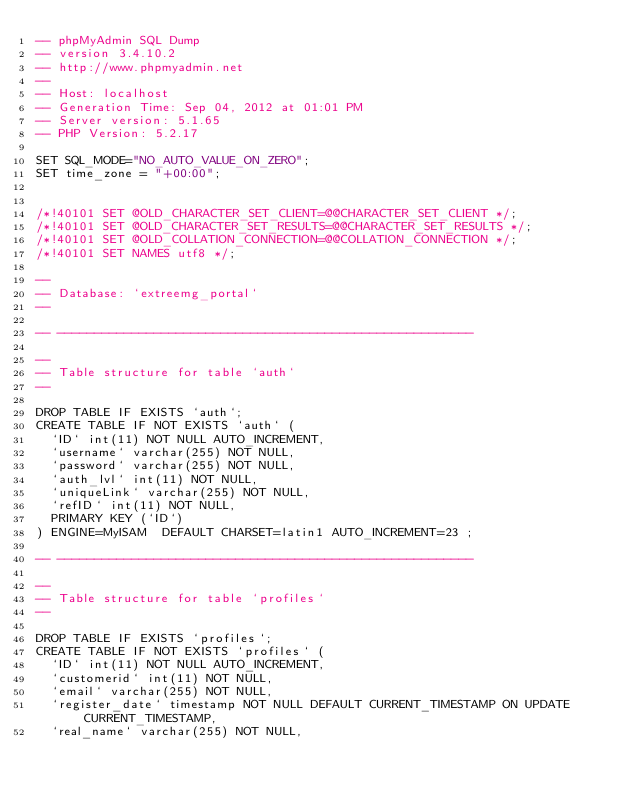<code> <loc_0><loc_0><loc_500><loc_500><_SQL_>-- phpMyAdmin SQL Dump
-- version 3.4.10.2
-- http://www.phpmyadmin.net
--
-- Host: localhost
-- Generation Time: Sep 04, 2012 at 01:01 PM
-- Server version: 5.1.65
-- PHP Version: 5.2.17

SET SQL_MODE="NO_AUTO_VALUE_ON_ZERO";
SET time_zone = "+00:00";


/*!40101 SET @OLD_CHARACTER_SET_CLIENT=@@CHARACTER_SET_CLIENT */;
/*!40101 SET @OLD_CHARACTER_SET_RESULTS=@@CHARACTER_SET_RESULTS */;
/*!40101 SET @OLD_COLLATION_CONNECTION=@@COLLATION_CONNECTION */;
/*!40101 SET NAMES utf8 */;

--
-- Database: `extreemg_portal`
--

-- --------------------------------------------------------

--
-- Table structure for table `auth`
--

DROP TABLE IF EXISTS `auth`;
CREATE TABLE IF NOT EXISTS `auth` (
  `ID` int(11) NOT NULL AUTO_INCREMENT,
  `username` varchar(255) NOT NULL,
  `password` varchar(255) NOT NULL,
  `auth_lvl` int(11) NOT NULL,
  `uniqueLink` varchar(255) NOT NULL,
  `refID` int(11) NOT NULL,
  PRIMARY KEY (`ID`)
) ENGINE=MyISAM  DEFAULT CHARSET=latin1 AUTO_INCREMENT=23 ;

-- --------------------------------------------------------

--
-- Table structure for table `profiles`
--

DROP TABLE IF EXISTS `profiles`;
CREATE TABLE IF NOT EXISTS `profiles` (
  `ID` int(11) NOT NULL AUTO_INCREMENT,
  `customerid` int(11) NOT NULL,
  `email` varchar(255) NOT NULL,
  `register_date` timestamp NOT NULL DEFAULT CURRENT_TIMESTAMP ON UPDATE CURRENT_TIMESTAMP,
  `real_name` varchar(255) NOT NULL,</code> 